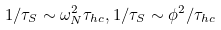Convert formula to latex. <formula><loc_0><loc_0><loc_500><loc_500>1 / \tau _ { S } \sim \omega _ { N } ^ { 2 } \tau _ { h c } , 1 / \tau _ { S } \sim \phi ^ { 2 } / \tau _ { h c }</formula> 